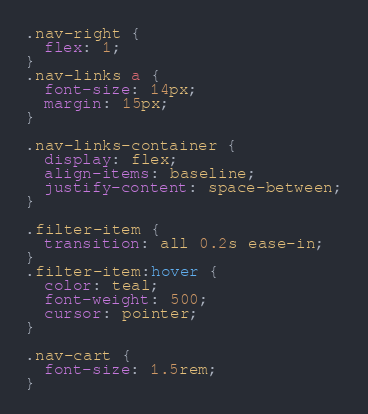Convert code to text. <code><loc_0><loc_0><loc_500><loc_500><_CSS_>.nav-right {
  flex: 1;
}
.nav-links a {
  font-size: 14px;
  margin: 15px;
}

.nav-links-container {
  display: flex;
  align-items: baseline;
  justify-content: space-between;
}

.filter-item {
  transition: all 0.2s ease-in;
}
.filter-item:hover {
  color: teal;
  font-weight: 500;
  cursor: pointer;
}

.nav-cart {
  font-size: 1.5rem;
}
</code> 